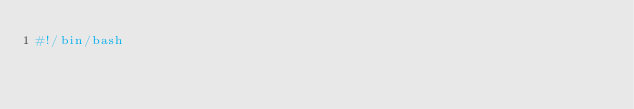Convert code to text. <code><loc_0><loc_0><loc_500><loc_500><_Bash_>#!/bin/bash
</code> 